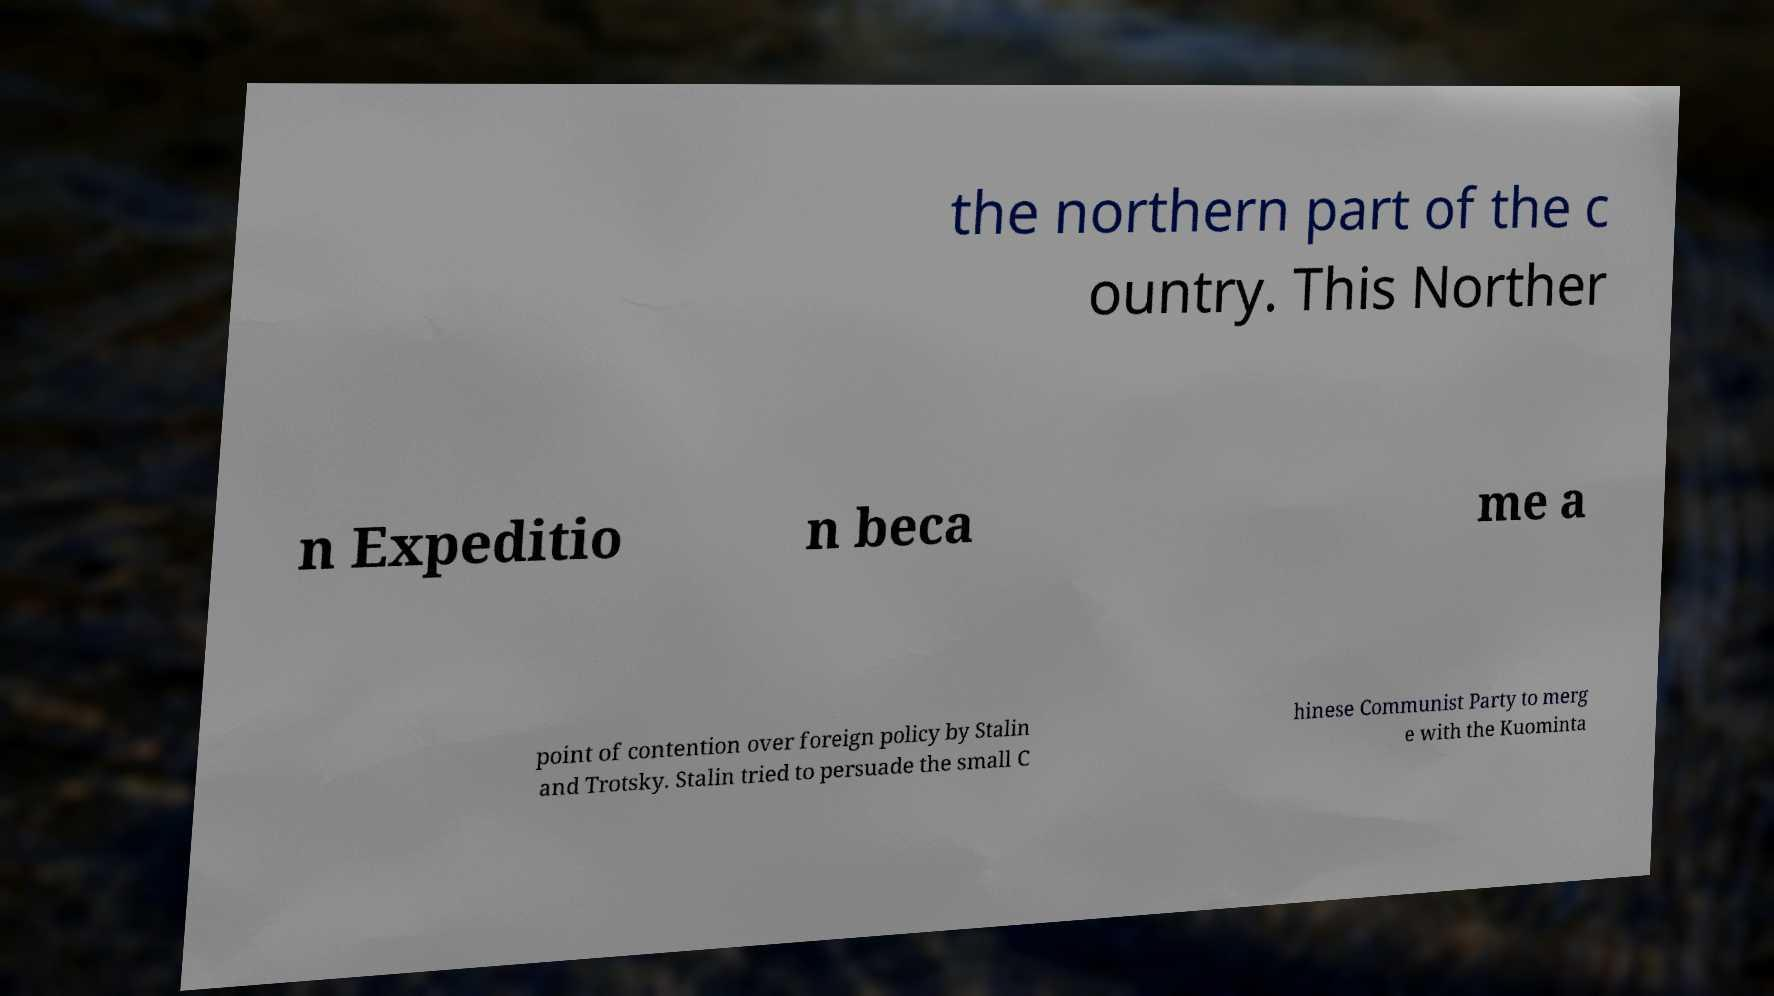Please read and relay the text visible in this image. What does it say? the northern part of the c ountry. This Norther n Expeditio n beca me a point of contention over foreign policy by Stalin and Trotsky. Stalin tried to persuade the small C hinese Communist Party to merg e with the Kuominta 